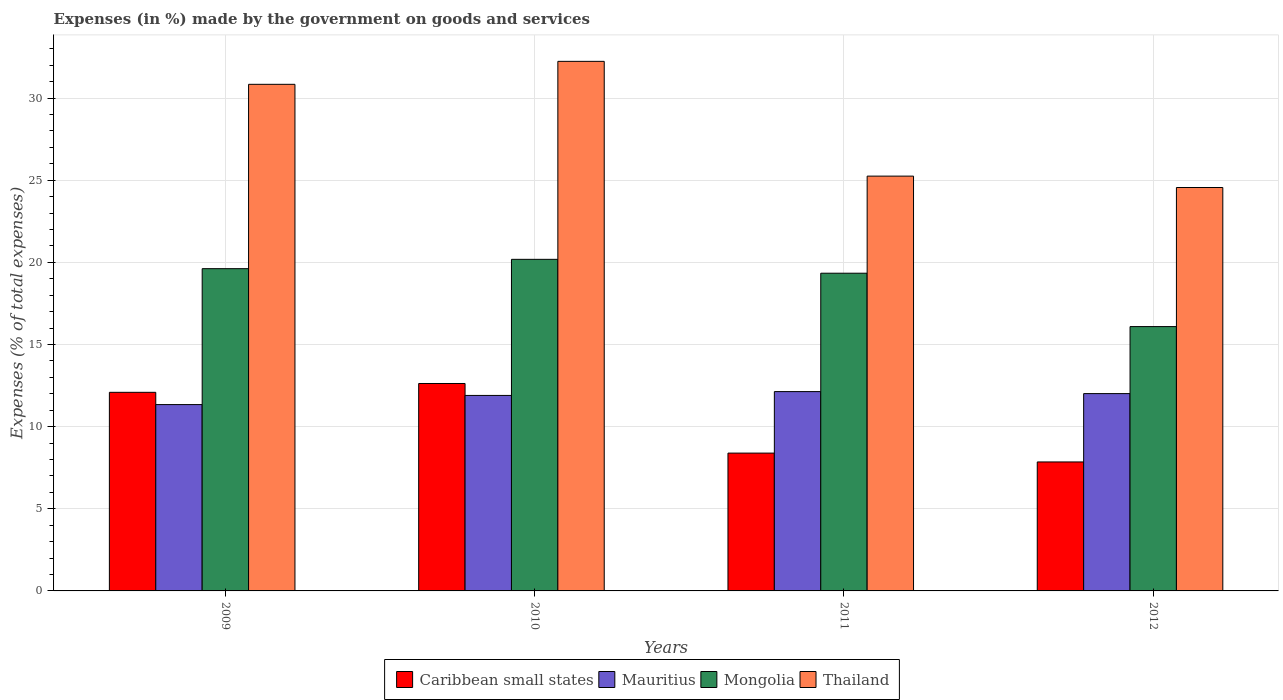How many different coloured bars are there?
Offer a very short reply. 4. Are the number of bars per tick equal to the number of legend labels?
Your response must be concise. Yes. Are the number of bars on each tick of the X-axis equal?
Keep it short and to the point. Yes. How many bars are there on the 4th tick from the right?
Ensure brevity in your answer.  4. In how many cases, is the number of bars for a given year not equal to the number of legend labels?
Provide a short and direct response. 0. What is the percentage of expenses made by the government on goods and services in Thailand in 2011?
Ensure brevity in your answer.  25.25. Across all years, what is the maximum percentage of expenses made by the government on goods and services in Mauritius?
Provide a short and direct response. 12.13. Across all years, what is the minimum percentage of expenses made by the government on goods and services in Mauritius?
Offer a terse response. 11.34. In which year was the percentage of expenses made by the government on goods and services in Mongolia maximum?
Keep it short and to the point. 2010. In which year was the percentage of expenses made by the government on goods and services in Caribbean small states minimum?
Give a very brief answer. 2012. What is the total percentage of expenses made by the government on goods and services in Caribbean small states in the graph?
Make the answer very short. 40.95. What is the difference between the percentage of expenses made by the government on goods and services in Caribbean small states in 2009 and that in 2011?
Make the answer very short. 3.7. What is the difference between the percentage of expenses made by the government on goods and services in Thailand in 2011 and the percentage of expenses made by the government on goods and services in Caribbean small states in 2009?
Keep it short and to the point. 13.16. What is the average percentage of expenses made by the government on goods and services in Mauritius per year?
Give a very brief answer. 11.85. In the year 2012, what is the difference between the percentage of expenses made by the government on goods and services in Mauritius and percentage of expenses made by the government on goods and services in Thailand?
Offer a very short reply. -12.54. What is the ratio of the percentage of expenses made by the government on goods and services in Caribbean small states in 2010 to that in 2011?
Your answer should be compact. 1.51. Is the percentage of expenses made by the government on goods and services in Mauritius in 2010 less than that in 2011?
Provide a short and direct response. Yes. What is the difference between the highest and the second highest percentage of expenses made by the government on goods and services in Thailand?
Your answer should be compact. 1.4. What is the difference between the highest and the lowest percentage of expenses made by the government on goods and services in Caribbean small states?
Your answer should be compact. 4.78. In how many years, is the percentage of expenses made by the government on goods and services in Mauritius greater than the average percentage of expenses made by the government on goods and services in Mauritius taken over all years?
Make the answer very short. 3. What does the 2nd bar from the left in 2011 represents?
Offer a terse response. Mauritius. What does the 2nd bar from the right in 2010 represents?
Offer a very short reply. Mongolia. How many bars are there?
Ensure brevity in your answer.  16. Are all the bars in the graph horizontal?
Ensure brevity in your answer.  No. What is the difference between two consecutive major ticks on the Y-axis?
Make the answer very short. 5. Are the values on the major ticks of Y-axis written in scientific E-notation?
Provide a succinct answer. No. Does the graph contain grids?
Provide a short and direct response. Yes. Where does the legend appear in the graph?
Make the answer very short. Bottom center. How many legend labels are there?
Provide a succinct answer. 4. What is the title of the graph?
Offer a terse response. Expenses (in %) made by the government on goods and services. Does "Tajikistan" appear as one of the legend labels in the graph?
Ensure brevity in your answer.  No. What is the label or title of the Y-axis?
Make the answer very short. Expenses (% of total expenses). What is the Expenses (% of total expenses) in Caribbean small states in 2009?
Your response must be concise. 12.09. What is the Expenses (% of total expenses) in Mauritius in 2009?
Ensure brevity in your answer.  11.34. What is the Expenses (% of total expenses) of Mongolia in 2009?
Your response must be concise. 19.62. What is the Expenses (% of total expenses) of Thailand in 2009?
Ensure brevity in your answer.  30.83. What is the Expenses (% of total expenses) of Caribbean small states in 2010?
Give a very brief answer. 12.63. What is the Expenses (% of total expenses) in Mauritius in 2010?
Offer a terse response. 11.9. What is the Expenses (% of total expenses) of Mongolia in 2010?
Your response must be concise. 20.18. What is the Expenses (% of total expenses) in Thailand in 2010?
Your response must be concise. 32.23. What is the Expenses (% of total expenses) of Caribbean small states in 2011?
Your response must be concise. 8.39. What is the Expenses (% of total expenses) in Mauritius in 2011?
Give a very brief answer. 12.13. What is the Expenses (% of total expenses) in Mongolia in 2011?
Give a very brief answer. 19.34. What is the Expenses (% of total expenses) in Thailand in 2011?
Your answer should be compact. 25.25. What is the Expenses (% of total expenses) of Caribbean small states in 2012?
Ensure brevity in your answer.  7.85. What is the Expenses (% of total expenses) in Mauritius in 2012?
Your response must be concise. 12.01. What is the Expenses (% of total expenses) of Mongolia in 2012?
Offer a terse response. 16.09. What is the Expenses (% of total expenses) in Thailand in 2012?
Keep it short and to the point. 24.55. Across all years, what is the maximum Expenses (% of total expenses) of Caribbean small states?
Give a very brief answer. 12.63. Across all years, what is the maximum Expenses (% of total expenses) in Mauritius?
Offer a terse response. 12.13. Across all years, what is the maximum Expenses (% of total expenses) in Mongolia?
Offer a very short reply. 20.18. Across all years, what is the maximum Expenses (% of total expenses) of Thailand?
Make the answer very short. 32.23. Across all years, what is the minimum Expenses (% of total expenses) of Caribbean small states?
Provide a short and direct response. 7.85. Across all years, what is the minimum Expenses (% of total expenses) of Mauritius?
Provide a short and direct response. 11.34. Across all years, what is the minimum Expenses (% of total expenses) of Mongolia?
Give a very brief answer. 16.09. Across all years, what is the minimum Expenses (% of total expenses) of Thailand?
Provide a short and direct response. 24.55. What is the total Expenses (% of total expenses) of Caribbean small states in the graph?
Your response must be concise. 40.95. What is the total Expenses (% of total expenses) of Mauritius in the graph?
Provide a succinct answer. 47.38. What is the total Expenses (% of total expenses) in Mongolia in the graph?
Keep it short and to the point. 75.22. What is the total Expenses (% of total expenses) in Thailand in the graph?
Give a very brief answer. 112.87. What is the difference between the Expenses (% of total expenses) in Caribbean small states in 2009 and that in 2010?
Make the answer very short. -0.54. What is the difference between the Expenses (% of total expenses) of Mauritius in 2009 and that in 2010?
Keep it short and to the point. -0.56. What is the difference between the Expenses (% of total expenses) in Mongolia in 2009 and that in 2010?
Your answer should be compact. -0.57. What is the difference between the Expenses (% of total expenses) of Thailand in 2009 and that in 2010?
Ensure brevity in your answer.  -1.4. What is the difference between the Expenses (% of total expenses) in Caribbean small states in 2009 and that in 2011?
Give a very brief answer. 3.7. What is the difference between the Expenses (% of total expenses) of Mauritius in 2009 and that in 2011?
Your answer should be compact. -0.79. What is the difference between the Expenses (% of total expenses) of Mongolia in 2009 and that in 2011?
Offer a very short reply. 0.28. What is the difference between the Expenses (% of total expenses) of Thailand in 2009 and that in 2011?
Provide a short and direct response. 5.59. What is the difference between the Expenses (% of total expenses) in Caribbean small states in 2009 and that in 2012?
Make the answer very short. 4.24. What is the difference between the Expenses (% of total expenses) of Mauritius in 2009 and that in 2012?
Give a very brief answer. -0.67. What is the difference between the Expenses (% of total expenses) in Mongolia in 2009 and that in 2012?
Provide a succinct answer. 3.53. What is the difference between the Expenses (% of total expenses) of Thailand in 2009 and that in 2012?
Give a very brief answer. 6.28. What is the difference between the Expenses (% of total expenses) in Caribbean small states in 2010 and that in 2011?
Keep it short and to the point. 4.24. What is the difference between the Expenses (% of total expenses) of Mauritius in 2010 and that in 2011?
Give a very brief answer. -0.23. What is the difference between the Expenses (% of total expenses) in Mongolia in 2010 and that in 2011?
Your answer should be compact. 0.84. What is the difference between the Expenses (% of total expenses) in Thailand in 2010 and that in 2011?
Provide a succinct answer. 6.99. What is the difference between the Expenses (% of total expenses) in Caribbean small states in 2010 and that in 2012?
Your answer should be very brief. 4.78. What is the difference between the Expenses (% of total expenses) of Mauritius in 2010 and that in 2012?
Provide a succinct answer. -0.11. What is the difference between the Expenses (% of total expenses) of Mongolia in 2010 and that in 2012?
Give a very brief answer. 4.09. What is the difference between the Expenses (% of total expenses) of Thailand in 2010 and that in 2012?
Provide a succinct answer. 7.68. What is the difference between the Expenses (% of total expenses) in Caribbean small states in 2011 and that in 2012?
Offer a terse response. 0.54. What is the difference between the Expenses (% of total expenses) of Mauritius in 2011 and that in 2012?
Your response must be concise. 0.12. What is the difference between the Expenses (% of total expenses) in Mongolia in 2011 and that in 2012?
Offer a terse response. 3.25. What is the difference between the Expenses (% of total expenses) in Thailand in 2011 and that in 2012?
Your answer should be very brief. 0.69. What is the difference between the Expenses (% of total expenses) in Caribbean small states in 2009 and the Expenses (% of total expenses) in Mauritius in 2010?
Your answer should be compact. 0.19. What is the difference between the Expenses (% of total expenses) in Caribbean small states in 2009 and the Expenses (% of total expenses) in Mongolia in 2010?
Ensure brevity in your answer.  -8.09. What is the difference between the Expenses (% of total expenses) of Caribbean small states in 2009 and the Expenses (% of total expenses) of Thailand in 2010?
Make the answer very short. -20.15. What is the difference between the Expenses (% of total expenses) of Mauritius in 2009 and the Expenses (% of total expenses) of Mongolia in 2010?
Your response must be concise. -8.84. What is the difference between the Expenses (% of total expenses) in Mauritius in 2009 and the Expenses (% of total expenses) in Thailand in 2010?
Give a very brief answer. -20.89. What is the difference between the Expenses (% of total expenses) in Mongolia in 2009 and the Expenses (% of total expenses) in Thailand in 2010?
Your response must be concise. -12.62. What is the difference between the Expenses (% of total expenses) of Caribbean small states in 2009 and the Expenses (% of total expenses) of Mauritius in 2011?
Keep it short and to the point. -0.04. What is the difference between the Expenses (% of total expenses) in Caribbean small states in 2009 and the Expenses (% of total expenses) in Mongolia in 2011?
Your answer should be very brief. -7.25. What is the difference between the Expenses (% of total expenses) in Caribbean small states in 2009 and the Expenses (% of total expenses) in Thailand in 2011?
Provide a short and direct response. -13.16. What is the difference between the Expenses (% of total expenses) in Mauritius in 2009 and the Expenses (% of total expenses) in Mongolia in 2011?
Your answer should be compact. -8. What is the difference between the Expenses (% of total expenses) of Mauritius in 2009 and the Expenses (% of total expenses) of Thailand in 2011?
Your answer should be compact. -13.91. What is the difference between the Expenses (% of total expenses) of Mongolia in 2009 and the Expenses (% of total expenses) of Thailand in 2011?
Your response must be concise. -5.63. What is the difference between the Expenses (% of total expenses) in Caribbean small states in 2009 and the Expenses (% of total expenses) in Mauritius in 2012?
Your answer should be compact. 0.08. What is the difference between the Expenses (% of total expenses) of Caribbean small states in 2009 and the Expenses (% of total expenses) of Mongolia in 2012?
Make the answer very short. -4. What is the difference between the Expenses (% of total expenses) of Caribbean small states in 2009 and the Expenses (% of total expenses) of Thailand in 2012?
Provide a succinct answer. -12.47. What is the difference between the Expenses (% of total expenses) in Mauritius in 2009 and the Expenses (% of total expenses) in Mongolia in 2012?
Provide a succinct answer. -4.75. What is the difference between the Expenses (% of total expenses) of Mauritius in 2009 and the Expenses (% of total expenses) of Thailand in 2012?
Your answer should be compact. -13.21. What is the difference between the Expenses (% of total expenses) in Mongolia in 2009 and the Expenses (% of total expenses) in Thailand in 2012?
Your answer should be very brief. -4.94. What is the difference between the Expenses (% of total expenses) of Caribbean small states in 2010 and the Expenses (% of total expenses) of Mauritius in 2011?
Provide a short and direct response. 0.49. What is the difference between the Expenses (% of total expenses) in Caribbean small states in 2010 and the Expenses (% of total expenses) in Mongolia in 2011?
Your answer should be compact. -6.71. What is the difference between the Expenses (% of total expenses) in Caribbean small states in 2010 and the Expenses (% of total expenses) in Thailand in 2011?
Ensure brevity in your answer.  -12.62. What is the difference between the Expenses (% of total expenses) in Mauritius in 2010 and the Expenses (% of total expenses) in Mongolia in 2011?
Provide a succinct answer. -7.44. What is the difference between the Expenses (% of total expenses) of Mauritius in 2010 and the Expenses (% of total expenses) of Thailand in 2011?
Offer a very short reply. -13.35. What is the difference between the Expenses (% of total expenses) of Mongolia in 2010 and the Expenses (% of total expenses) of Thailand in 2011?
Make the answer very short. -5.07. What is the difference between the Expenses (% of total expenses) in Caribbean small states in 2010 and the Expenses (% of total expenses) in Mauritius in 2012?
Offer a very short reply. 0.62. What is the difference between the Expenses (% of total expenses) in Caribbean small states in 2010 and the Expenses (% of total expenses) in Mongolia in 2012?
Ensure brevity in your answer.  -3.46. What is the difference between the Expenses (% of total expenses) of Caribbean small states in 2010 and the Expenses (% of total expenses) of Thailand in 2012?
Offer a very short reply. -11.93. What is the difference between the Expenses (% of total expenses) of Mauritius in 2010 and the Expenses (% of total expenses) of Mongolia in 2012?
Your answer should be compact. -4.19. What is the difference between the Expenses (% of total expenses) of Mauritius in 2010 and the Expenses (% of total expenses) of Thailand in 2012?
Offer a very short reply. -12.66. What is the difference between the Expenses (% of total expenses) in Mongolia in 2010 and the Expenses (% of total expenses) in Thailand in 2012?
Your answer should be compact. -4.37. What is the difference between the Expenses (% of total expenses) of Caribbean small states in 2011 and the Expenses (% of total expenses) of Mauritius in 2012?
Ensure brevity in your answer.  -3.62. What is the difference between the Expenses (% of total expenses) in Caribbean small states in 2011 and the Expenses (% of total expenses) in Mongolia in 2012?
Give a very brief answer. -7.7. What is the difference between the Expenses (% of total expenses) in Caribbean small states in 2011 and the Expenses (% of total expenses) in Thailand in 2012?
Provide a succinct answer. -16.17. What is the difference between the Expenses (% of total expenses) of Mauritius in 2011 and the Expenses (% of total expenses) of Mongolia in 2012?
Your response must be concise. -3.96. What is the difference between the Expenses (% of total expenses) in Mauritius in 2011 and the Expenses (% of total expenses) in Thailand in 2012?
Your answer should be very brief. -12.42. What is the difference between the Expenses (% of total expenses) in Mongolia in 2011 and the Expenses (% of total expenses) in Thailand in 2012?
Give a very brief answer. -5.22. What is the average Expenses (% of total expenses) in Caribbean small states per year?
Your answer should be very brief. 10.24. What is the average Expenses (% of total expenses) of Mauritius per year?
Keep it short and to the point. 11.85. What is the average Expenses (% of total expenses) in Mongolia per year?
Your answer should be very brief. 18.81. What is the average Expenses (% of total expenses) of Thailand per year?
Your answer should be very brief. 28.22. In the year 2009, what is the difference between the Expenses (% of total expenses) of Caribbean small states and Expenses (% of total expenses) of Mauritius?
Provide a succinct answer. 0.75. In the year 2009, what is the difference between the Expenses (% of total expenses) in Caribbean small states and Expenses (% of total expenses) in Mongolia?
Provide a succinct answer. -7.53. In the year 2009, what is the difference between the Expenses (% of total expenses) of Caribbean small states and Expenses (% of total expenses) of Thailand?
Your answer should be compact. -18.75. In the year 2009, what is the difference between the Expenses (% of total expenses) of Mauritius and Expenses (% of total expenses) of Mongolia?
Provide a short and direct response. -8.27. In the year 2009, what is the difference between the Expenses (% of total expenses) of Mauritius and Expenses (% of total expenses) of Thailand?
Make the answer very short. -19.49. In the year 2009, what is the difference between the Expenses (% of total expenses) of Mongolia and Expenses (% of total expenses) of Thailand?
Make the answer very short. -11.22. In the year 2010, what is the difference between the Expenses (% of total expenses) of Caribbean small states and Expenses (% of total expenses) of Mauritius?
Give a very brief answer. 0.73. In the year 2010, what is the difference between the Expenses (% of total expenses) in Caribbean small states and Expenses (% of total expenses) in Mongolia?
Your answer should be very brief. -7.56. In the year 2010, what is the difference between the Expenses (% of total expenses) in Caribbean small states and Expenses (% of total expenses) in Thailand?
Provide a short and direct response. -19.61. In the year 2010, what is the difference between the Expenses (% of total expenses) in Mauritius and Expenses (% of total expenses) in Mongolia?
Your answer should be compact. -8.28. In the year 2010, what is the difference between the Expenses (% of total expenses) in Mauritius and Expenses (% of total expenses) in Thailand?
Offer a terse response. -20.33. In the year 2010, what is the difference between the Expenses (% of total expenses) in Mongolia and Expenses (% of total expenses) in Thailand?
Keep it short and to the point. -12.05. In the year 2011, what is the difference between the Expenses (% of total expenses) in Caribbean small states and Expenses (% of total expenses) in Mauritius?
Provide a short and direct response. -3.74. In the year 2011, what is the difference between the Expenses (% of total expenses) of Caribbean small states and Expenses (% of total expenses) of Mongolia?
Give a very brief answer. -10.95. In the year 2011, what is the difference between the Expenses (% of total expenses) of Caribbean small states and Expenses (% of total expenses) of Thailand?
Make the answer very short. -16.86. In the year 2011, what is the difference between the Expenses (% of total expenses) in Mauritius and Expenses (% of total expenses) in Mongolia?
Provide a succinct answer. -7.21. In the year 2011, what is the difference between the Expenses (% of total expenses) of Mauritius and Expenses (% of total expenses) of Thailand?
Provide a succinct answer. -13.12. In the year 2011, what is the difference between the Expenses (% of total expenses) of Mongolia and Expenses (% of total expenses) of Thailand?
Your response must be concise. -5.91. In the year 2012, what is the difference between the Expenses (% of total expenses) in Caribbean small states and Expenses (% of total expenses) in Mauritius?
Your answer should be compact. -4.16. In the year 2012, what is the difference between the Expenses (% of total expenses) of Caribbean small states and Expenses (% of total expenses) of Mongolia?
Provide a succinct answer. -8.24. In the year 2012, what is the difference between the Expenses (% of total expenses) in Caribbean small states and Expenses (% of total expenses) in Thailand?
Offer a terse response. -16.7. In the year 2012, what is the difference between the Expenses (% of total expenses) in Mauritius and Expenses (% of total expenses) in Mongolia?
Give a very brief answer. -4.08. In the year 2012, what is the difference between the Expenses (% of total expenses) of Mauritius and Expenses (% of total expenses) of Thailand?
Make the answer very short. -12.54. In the year 2012, what is the difference between the Expenses (% of total expenses) of Mongolia and Expenses (% of total expenses) of Thailand?
Provide a succinct answer. -8.47. What is the ratio of the Expenses (% of total expenses) of Caribbean small states in 2009 to that in 2010?
Your response must be concise. 0.96. What is the ratio of the Expenses (% of total expenses) in Mauritius in 2009 to that in 2010?
Make the answer very short. 0.95. What is the ratio of the Expenses (% of total expenses) of Mongolia in 2009 to that in 2010?
Provide a short and direct response. 0.97. What is the ratio of the Expenses (% of total expenses) in Thailand in 2009 to that in 2010?
Your answer should be compact. 0.96. What is the ratio of the Expenses (% of total expenses) of Caribbean small states in 2009 to that in 2011?
Make the answer very short. 1.44. What is the ratio of the Expenses (% of total expenses) in Mauritius in 2009 to that in 2011?
Your answer should be very brief. 0.93. What is the ratio of the Expenses (% of total expenses) in Mongolia in 2009 to that in 2011?
Your answer should be compact. 1.01. What is the ratio of the Expenses (% of total expenses) of Thailand in 2009 to that in 2011?
Your answer should be very brief. 1.22. What is the ratio of the Expenses (% of total expenses) of Caribbean small states in 2009 to that in 2012?
Make the answer very short. 1.54. What is the ratio of the Expenses (% of total expenses) in Mongolia in 2009 to that in 2012?
Your response must be concise. 1.22. What is the ratio of the Expenses (% of total expenses) in Thailand in 2009 to that in 2012?
Your answer should be compact. 1.26. What is the ratio of the Expenses (% of total expenses) in Caribbean small states in 2010 to that in 2011?
Your response must be concise. 1.51. What is the ratio of the Expenses (% of total expenses) in Mauritius in 2010 to that in 2011?
Your response must be concise. 0.98. What is the ratio of the Expenses (% of total expenses) in Mongolia in 2010 to that in 2011?
Offer a terse response. 1.04. What is the ratio of the Expenses (% of total expenses) of Thailand in 2010 to that in 2011?
Ensure brevity in your answer.  1.28. What is the ratio of the Expenses (% of total expenses) in Caribbean small states in 2010 to that in 2012?
Offer a very short reply. 1.61. What is the ratio of the Expenses (% of total expenses) of Mongolia in 2010 to that in 2012?
Provide a succinct answer. 1.25. What is the ratio of the Expenses (% of total expenses) of Thailand in 2010 to that in 2012?
Give a very brief answer. 1.31. What is the ratio of the Expenses (% of total expenses) in Caribbean small states in 2011 to that in 2012?
Your answer should be very brief. 1.07. What is the ratio of the Expenses (% of total expenses) of Mauritius in 2011 to that in 2012?
Make the answer very short. 1.01. What is the ratio of the Expenses (% of total expenses) of Mongolia in 2011 to that in 2012?
Offer a very short reply. 1.2. What is the ratio of the Expenses (% of total expenses) in Thailand in 2011 to that in 2012?
Keep it short and to the point. 1.03. What is the difference between the highest and the second highest Expenses (% of total expenses) of Caribbean small states?
Offer a very short reply. 0.54. What is the difference between the highest and the second highest Expenses (% of total expenses) in Mauritius?
Provide a short and direct response. 0.12. What is the difference between the highest and the second highest Expenses (% of total expenses) in Mongolia?
Provide a short and direct response. 0.57. What is the difference between the highest and the second highest Expenses (% of total expenses) of Thailand?
Ensure brevity in your answer.  1.4. What is the difference between the highest and the lowest Expenses (% of total expenses) of Caribbean small states?
Provide a succinct answer. 4.78. What is the difference between the highest and the lowest Expenses (% of total expenses) in Mauritius?
Keep it short and to the point. 0.79. What is the difference between the highest and the lowest Expenses (% of total expenses) in Mongolia?
Provide a succinct answer. 4.09. What is the difference between the highest and the lowest Expenses (% of total expenses) of Thailand?
Your answer should be very brief. 7.68. 